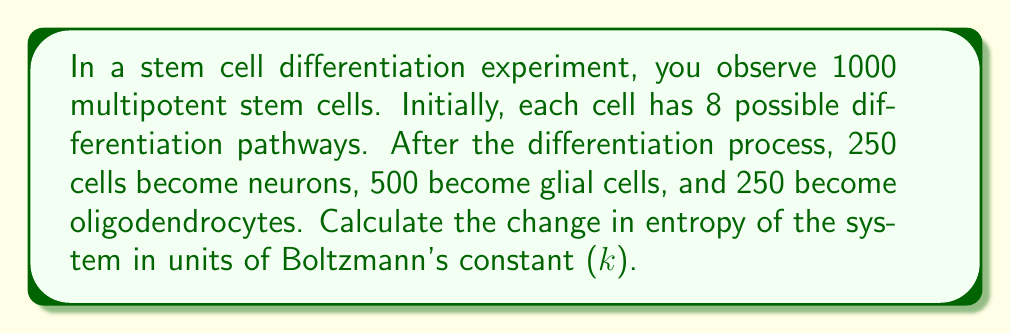Can you solve this math problem? To calculate the change in entropy, we need to determine the entropy before and after the differentiation process.

Step 1: Calculate the initial entropy
Initially, each cell has 8 possible states.
$$S_i = k \ln W_i = k \ln 8^{1000} = 1000k \ln 8$$

Step 2: Calculate the final entropy
After differentiation, we have:
250 neurons: $W_1 = 1$
500 glial cells: $W_2 = 1$
250 oligodendrocytes: $W_3 = 1$

The total number of microstates is:
$$W_f = \frac{1000!}{250! \cdot 500! \cdot 250!}$$

The final entropy is:
$$S_f = k \ln W_f = k \ln \frac{1000!}{250! \cdot 500! \cdot 250!}$$

Step 3: Calculate the change in entropy
$$\Delta S = S_f - S_i = k \ln \frac{1000!}{250! \cdot 500! \cdot 250!} - 1000k \ln 8$$

Step 4: Simplify using Stirling's approximation
$$\ln N! \approx N \ln N - N$$

Applying this to our equation:

$$\begin{align*}
\Delta S &= k[(1000 \ln 1000 - 1000) - (250 \ln 250 - 250) - (500 \ln 500 - 500) - (250 \ln 250 - 250) - 1000 \ln 8] \\
&= k[1000 \ln 1000 - 250 \ln 250 - 500 \ln 500 - 250 \ln 250 - 1000 \ln 8] \\
&\approx -5308.67k
\end{align*}$$
Answer: $\Delta S \approx -5308.67k$ 